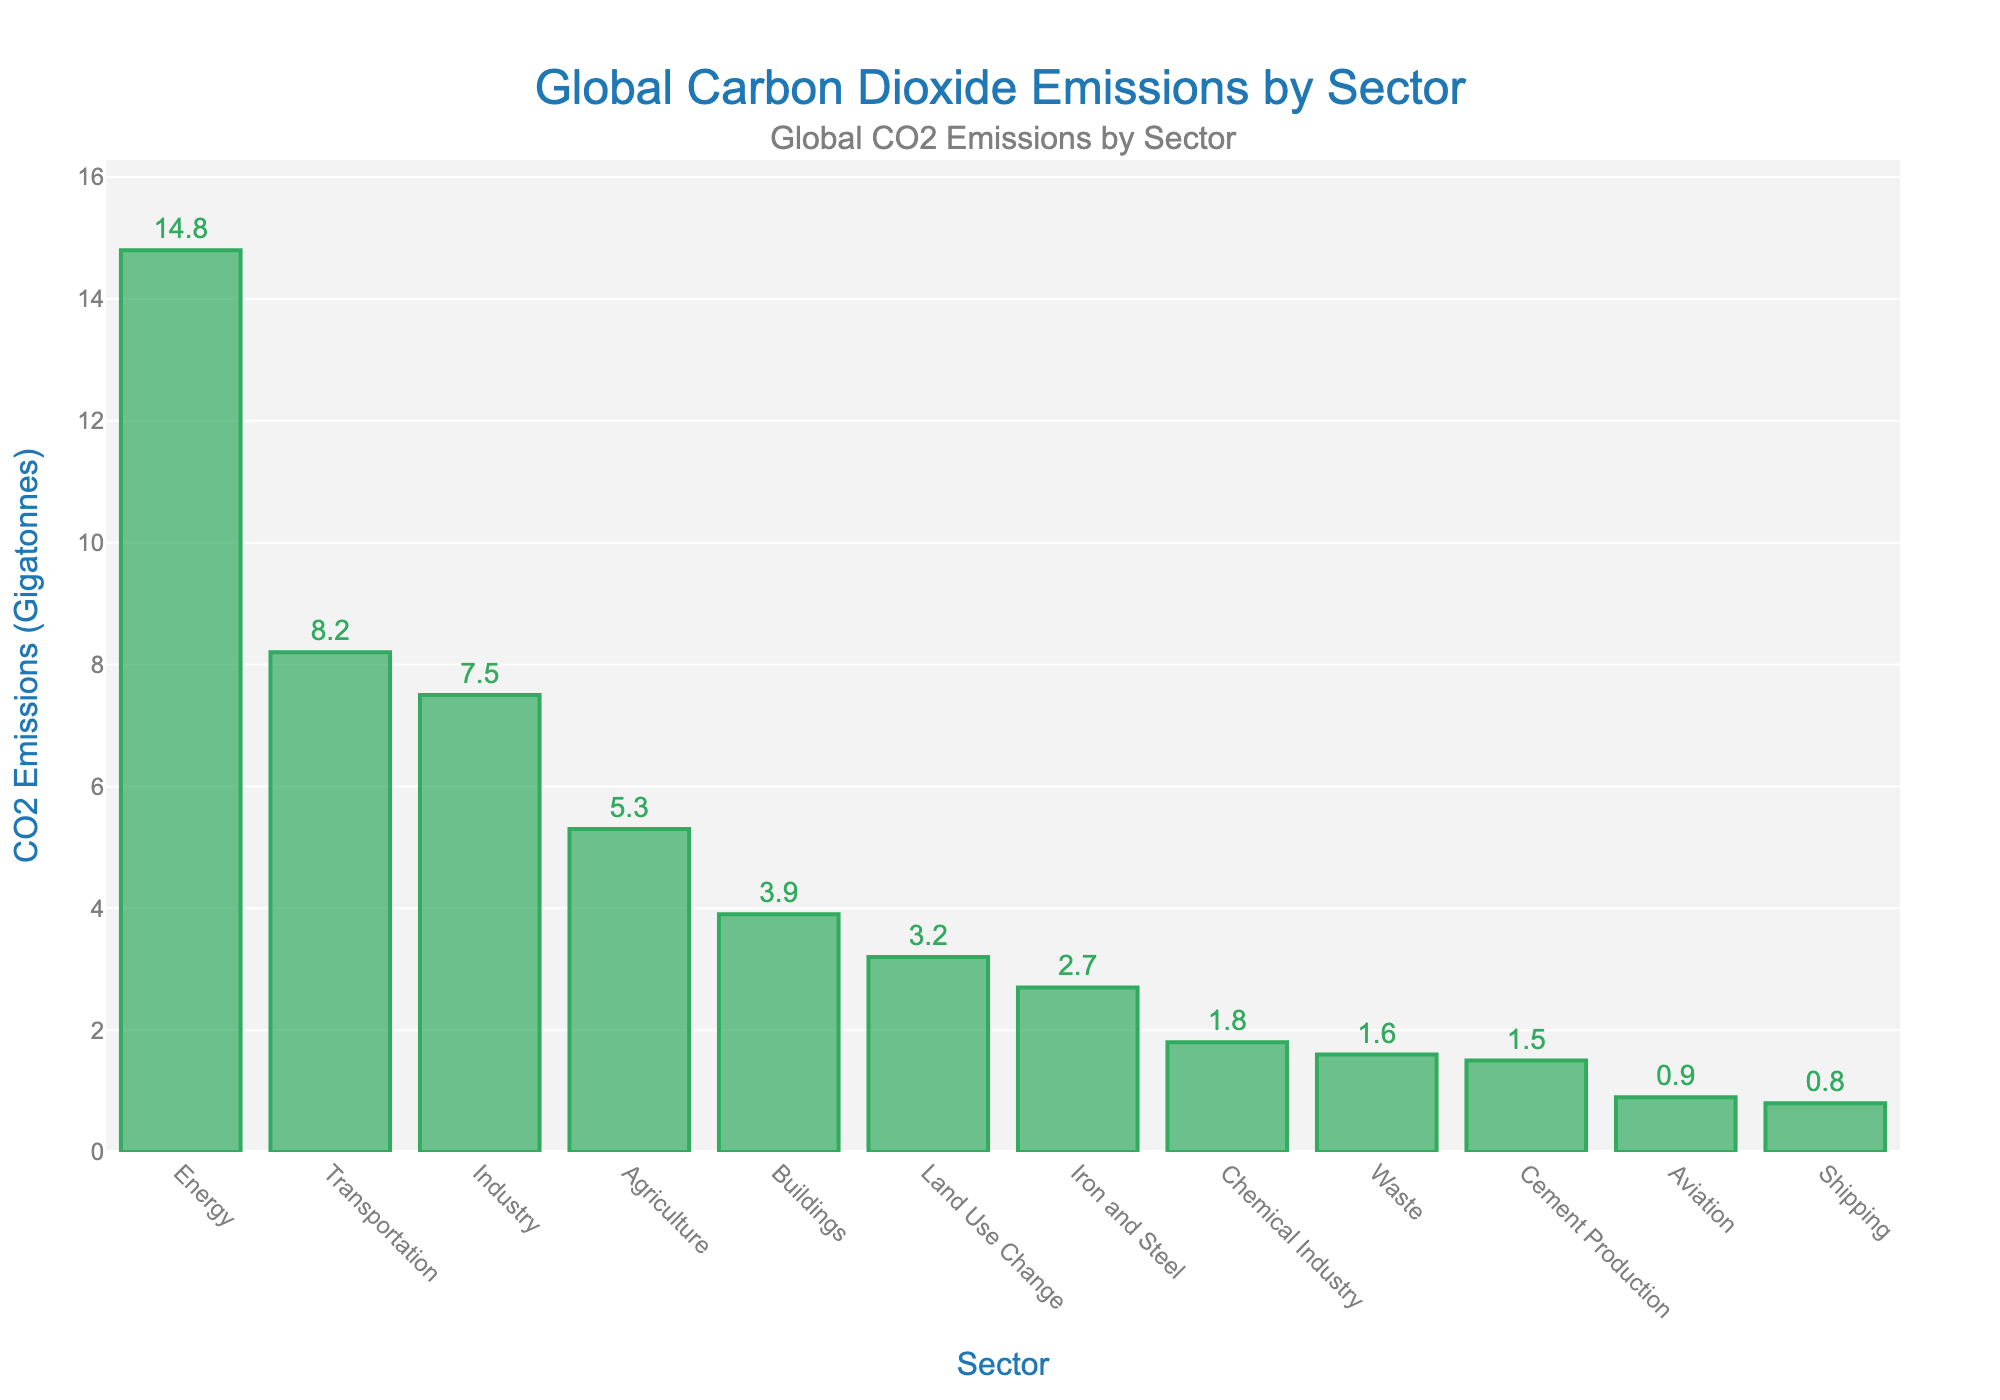What sector contributes the most to CO2 emissions? The highest bar on the chart represents the sector that contributes the most to CO2 emissions. Here, the 'Energy' sector has the tallest bar, indicating the highest CO2 emissions at 14.8 Gt.
Answer: Energy Which sector has higher CO2 emissions: Transportation or Industry? Compare the height of the bars for 'Transportation' and 'Industry'. The 'Transportation' sector emits 8.2 Gt, which is higher than the 'Industry' sector at 7.5 Gt.
Answer: Transportation What is the combined CO2 emission of the Agriculture and Buildings sectors? Sum the CO2 emissions from the 'Agriculture' (5.3 Gt) and 'Buildings' (3.9 Gt) sectors: 5.3 + 3.9 = 9.2 Gt.
Answer: 9.2 Gt How does the CO2 emission of Aviation compare to Shipping? Compare the height of the bars for 'Aviation' and 'Shipping'. 'Aviation' emits 0.9 Gt and 'Shipping' emits 0.8 Gt, so Aviation has slightly higher emissions.
Answer: Aviation Which sectors have CO2 emissions less than 2 Gt? Identify all bars with heights representing emission values less than 2 Gt. These sectors are 'Aviation' (0.9 Gt), 'Shipping' (0.8 Gt), 'Cement Production' (1.5 Gt), and 'Waste' (1.6 Gt).
Answer: Aviation, Shipping, Cement Production, Waste What is the difference in CO2 emissions between the Energy and Iron and Steel sectors? Subtract the CO2 emissions of 'Iron and Steel' (2.7 Gt) from 'Energy' (14.8 Gt): 14.8 - 2.7 = 12.1 Gt.
Answer: 12.1 Gt Arrange the following sectors in ascending order of their CO2 emissions: Chemical Industry, Energy, Agriculture, Waste. List the emissions and sort them: Waste (1.6 Gt), Chemical Industry (1.8 Gt), Agriculture (5.3 Gt), Energy (14.8 Gt).
Answer: Waste, Chemical Industry, Agriculture, Energy What is the average CO2 emission of the top three emitting sectors? First, identify the top three emitting sectors: Energy (14.8 Gt), Transportation (8.2 Gt), and Industry (7.5 Gt). Calculate the average: (14.8 + 8.2 + 7.5) / 3 = 10.167 Gt.
Answer: 10.167 Gt Is the 'Transportation' sector emission more than double that of the 'Buildings' sector? Compare 'Transportation' (8.2 Gt) with double 'Buildings' (2 * 3.9 Gt = 7.8 Gt). Since 8.2 Gt > 7.8 Gt, the emission from 'Transportation' is more than double that of 'Buildings'.
Answer: Yes What proportion of CO2 emissions does the 'Land Use Change' sector contribute compared to the 'Industry' sector? Calculate the proportion of 'Land Use Change' (3.2 Gt) to 'Industry' (7.5 Gt): 3.2 / 7.5 ≈ 0.427 or 42.7%.
Answer: 42.7% 